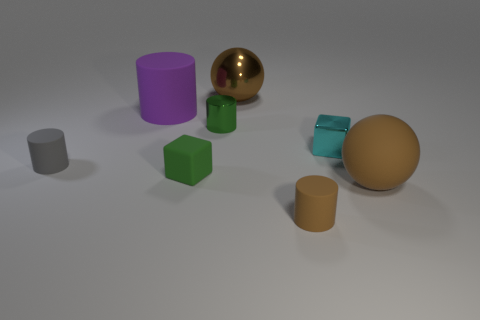Are there any brown cylinders that have the same material as the cyan cube?
Your response must be concise. No. Are there any other things that have the same material as the big purple thing?
Ensure brevity in your answer.  Yes. The metallic cylinder is what color?
Offer a very short reply. Green. There is another big thing that is the same color as the big metallic thing; what is its shape?
Make the answer very short. Sphere. The other rubber thing that is the same size as the purple matte object is what color?
Offer a very short reply. Brown. What number of rubber things are large purple balls or small cyan blocks?
Offer a terse response. 0. How many rubber cylinders are both behind the green rubber cube and in front of the tiny matte block?
Offer a terse response. 0. Is there any other thing that has the same shape as the small cyan thing?
Make the answer very short. Yes. How many other objects are there of the same size as the gray rubber cylinder?
Provide a succinct answer. 4. Do the matte cylinder in front of the gray matte object and the block that is to the right of the brown cylinder have the same size?
Provide a succinct answer. Yes. 